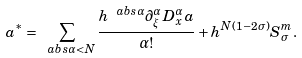<formula> <loc_0><loc_0><loc_500><loc_500>a ^ { * } = \sum _ { \ a b s { \alpha } < N } \frac { h ^ { \ a b s { \alpha } } \partial _ { \xi } ^ { \alpha } D _ { x } ^ { \alpha } a } { \alpha ! } + h ^ { N ( 1 - 2 \sigma ) } S ^ { m } _ { \sigma } .</formula> 